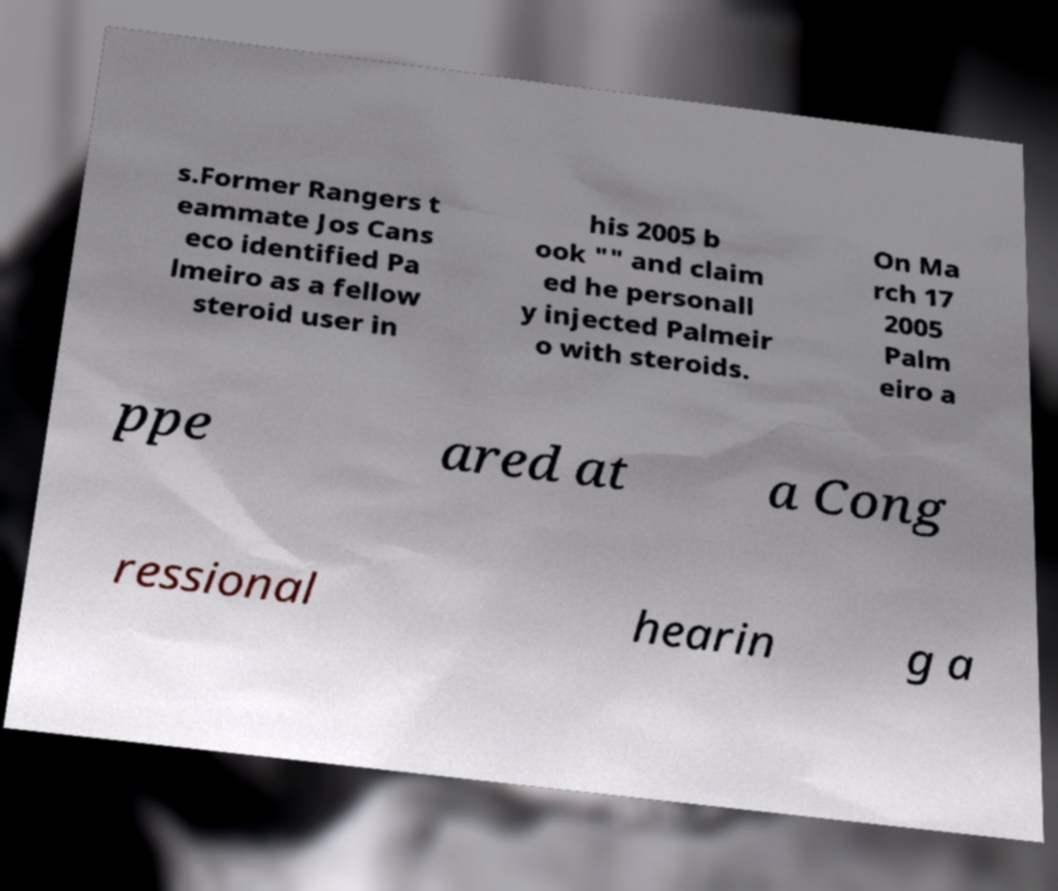I need the written content from this picture converted into text. Can you do that? s.Former Rangers t eammate Jos Cans eco identified Pa lmeiro as a fellow steroid user in his 2005 b ook "" and claim ed he personall y injected Palmeir o with steroids. On Ma rch 17 2005 Palm eiro a ppe ared at a Cong ressional hearin g a 